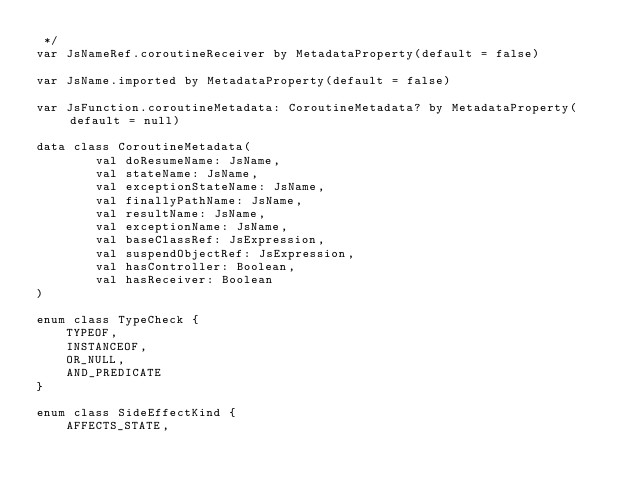<code> <loc_0><loc_0><loc_500><loc_500><_Kotlin_> */
var JsNameRef.coroutineReceiver by MetadataProperty(default = false)

var JsName.imported by MetadataProperty(default = false)

var JsFunction.coroutineMetadata: CoroutineMetadata? by MetadataProperty(default = null)

data class CoroutineMetadata(
        val doResumeName: JsName,
        val stateName: JsName,
        val exceptionStateName: JsName,
        val finallyPathName: JsName,
        val resultName: JsName,
        val exceptionName: JsName,
        val baseClassRef: JsExpression,
        val suspendObjectRef: JsExpression,
        val hasController: Boolean,
        val hasReceiver: Boolean
)

enum class TypeCheck {
    TYPEOF,
    INSTANCEOF,
    OR_NULL,
    AND_PREDICATE
}

enum class SideEffectKind {
    AFFECTS_STATE,</code> 